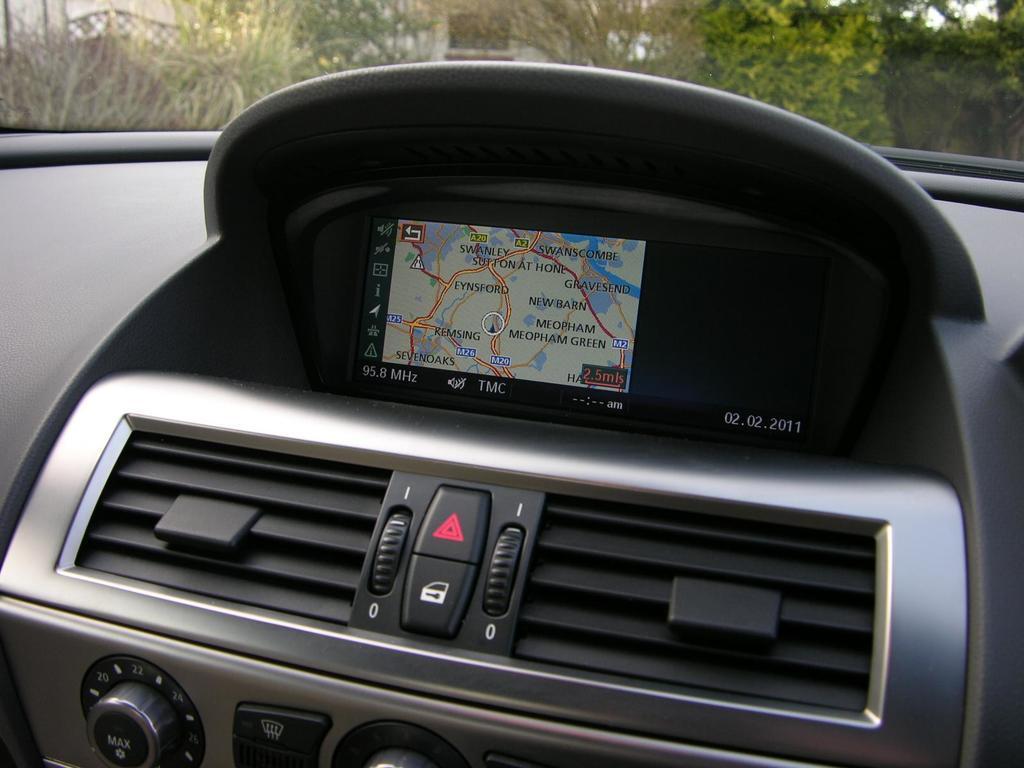Could you give a brief overview of what you see in this image? In this image we can see an inside of a car. There are many trees in the image. We can see a digital screen, tuners, etc., in the car. 